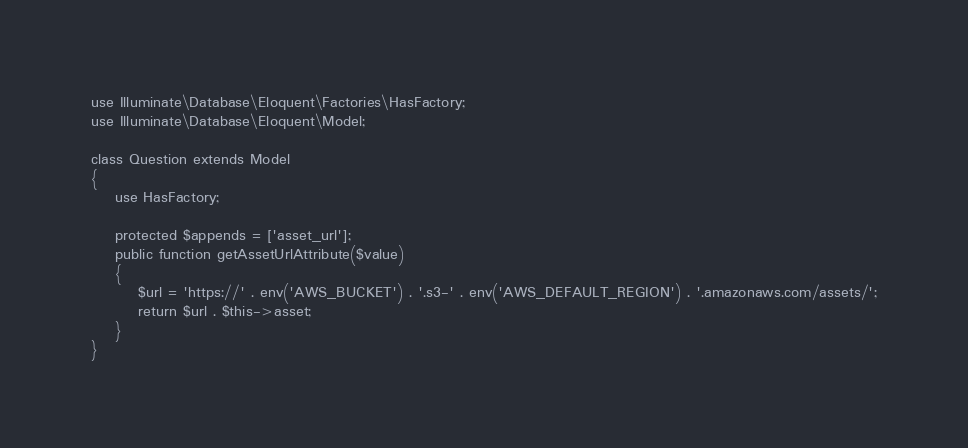Convert code to text. <code><loc_0><loc_0><loc_500><loc_500><_PHP_>
use Illuminate\Database\Eloquent\Factories\HasFactory;
use Illuminate\Database\Eloquent\Model;

class Question extends Model
{
    use HasFactory;

    protected $appends = ['asset_url'];
    public function getAssetUrlAttribute($value)
    {
        $url = 'https://' . env('AWS_BUCKET') . '.s3-' . env('AWS_DEFAULT_REGION') . '.amazonaws.com/assets/';
        return $url . $this->asset;
    }
}
</code> 